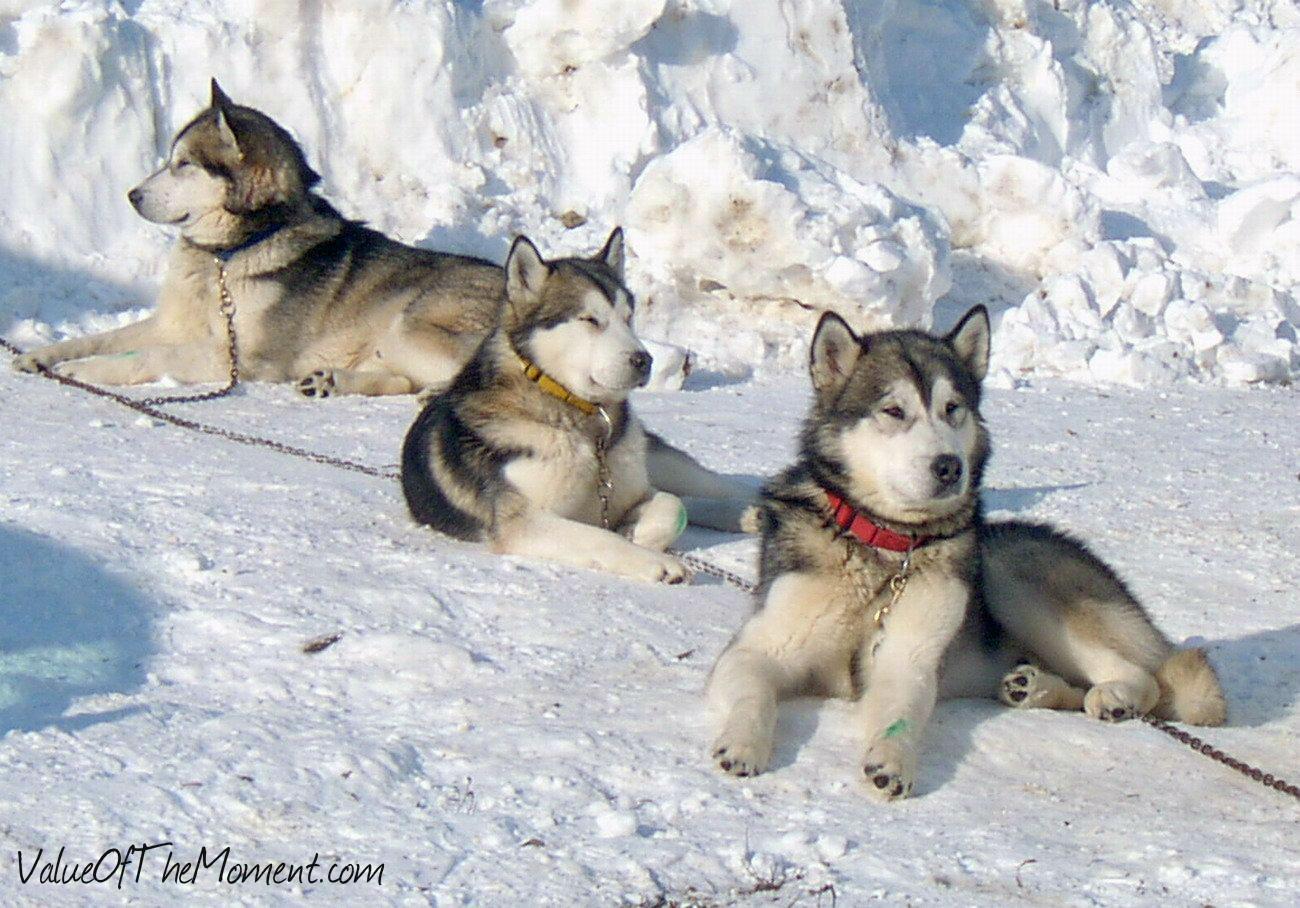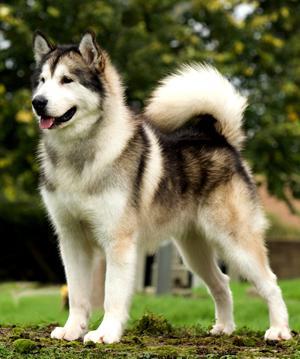The first image is the image on the left, the second image is the image on the right. Evaluate the accuracy of this statement regarding the images: "The right image shows a non-standing adult husky dog with its head upright, and the left image shows a husky puppy with its head down but its eyes gazing upward.". Is it true? Answer yes or no. No. 